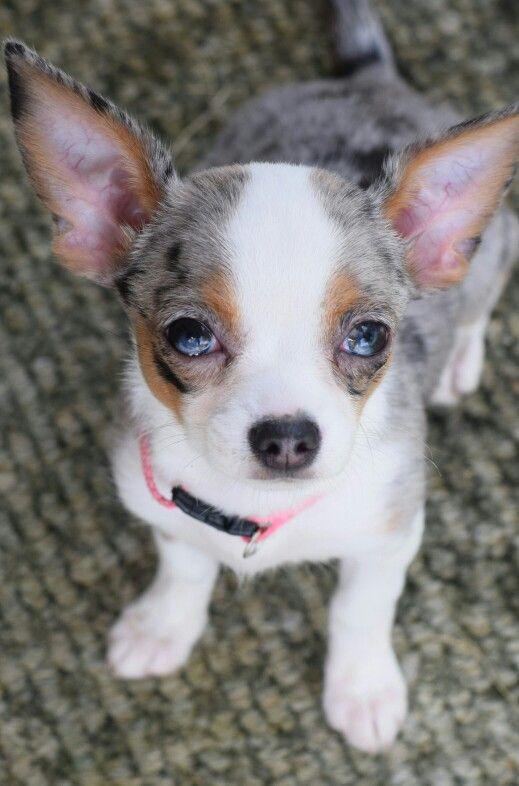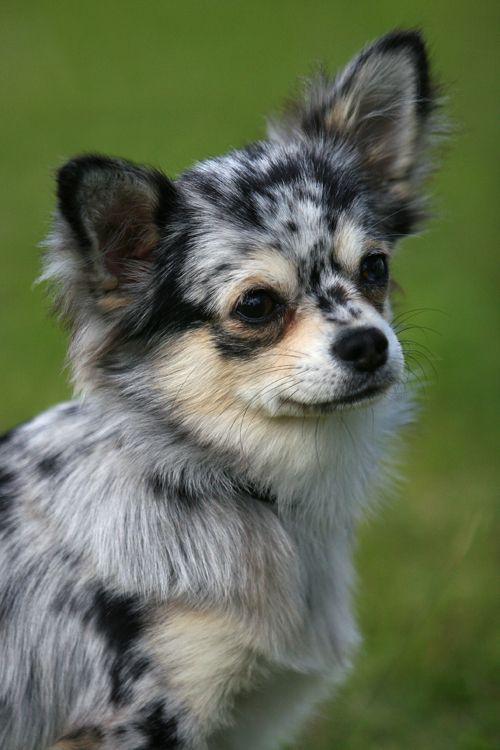The first image is the image on the left, the second image is the image on the right. Examine the images to the left and right. Is the description "there are at least five animals in one of the images" accurate? Answer yes or no. No. The first image is the image on the left, the second image is the image on the right. Assess this claim about the two images: "There are 2 dogs with heads that are at least level.". Correct or not? Answer yes or no. Yes. The first image is the image on the left, the second image is the image on the right. Assess this claim about the two images: "Exactly two little dogs are shown, one wearing a collar.". Correct or not? Answer yes or no. Yes. The first image is the image on the left, the second image is the image on the right. Assess this claim about the two images: "There are two dogs". Correct or not? Answer yes or no. Yes. 